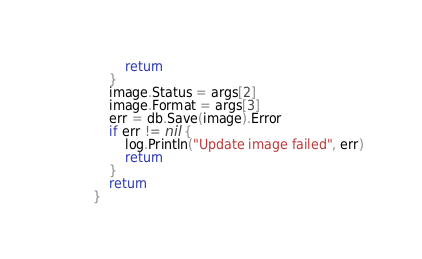<code> <loc_0><loc_0><loc_500><loc_500><_Go_>		return
	}
	image.Status = args[2]
	image.Format = args[3]
	err = db.Save(image).Error
	if err != nil {
		log.Println("Update image failed", err)
		return
	}
	return
}
</code> 